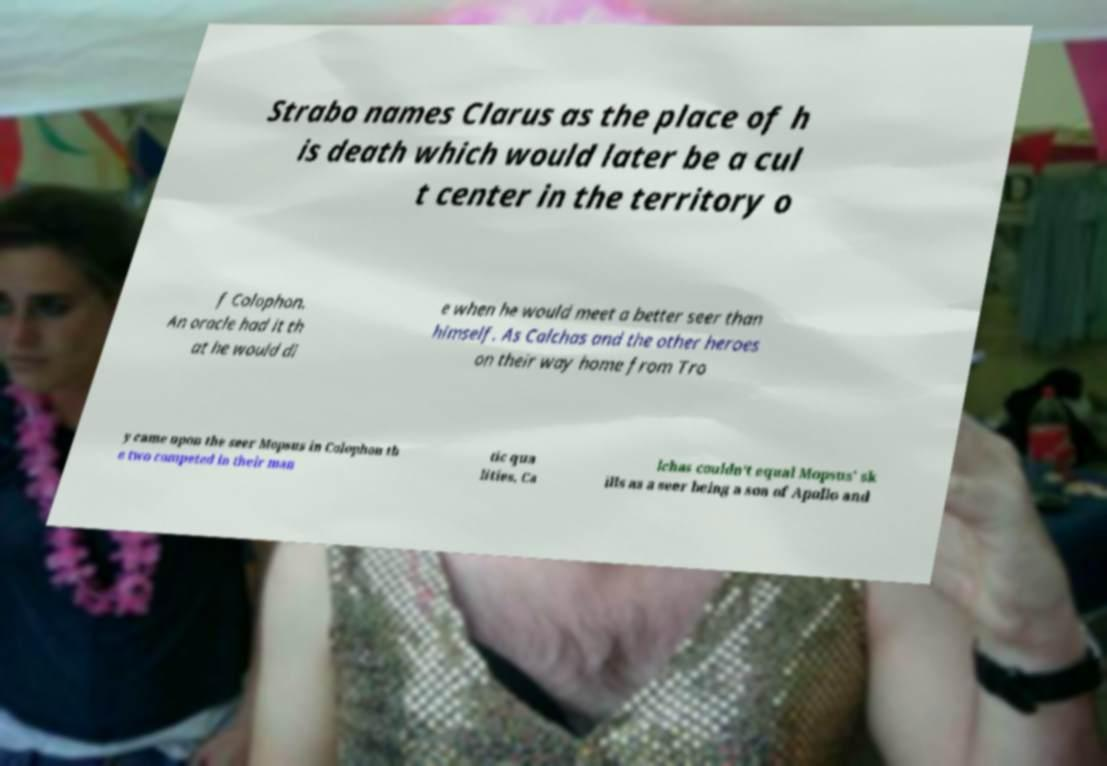Please read and relay the text visible in this image. What does it say? Strabo names Clarus as the place of h is death which would later be a cul t center in the territory o f Colophon. An oracle had it th at he would di e when he would meet a better seer than himself. As Calchas and the other heroes on their way home from Tro y came upon the seer Mopsus in Colophon th e two competed in their man tic qua lities. Ca lchas couldn't equal Mopsus' sk ills as a seer being a son of Apollo and 